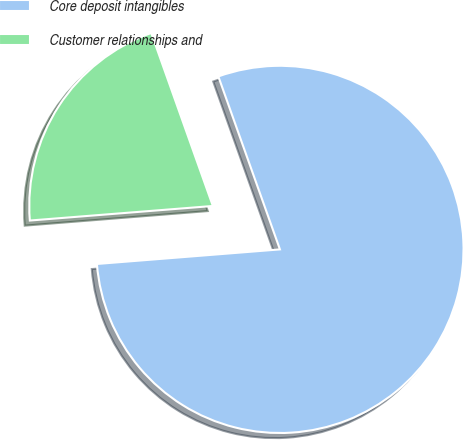Convert chart. <chart><loc_0><loc_0><loc_500><loc_500><pie_chart><fcel>Core deposit intangibles<fcel>Customer relationships and<nl><fcel>79.18%<fcel>20.82%<nl></chart> 